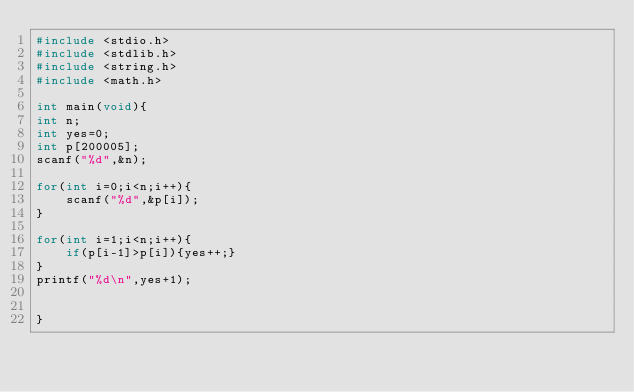<code> <loc_0><loc_0><loc_500><loc_500><_C_>#include <stdio.h>
#include <stdlib.h>
#include <string.h>
#include <math.h>

int main(void){
int n;
int yes=0;
int p[200005];
scanf("%d",&n);

for(int i=0;i<n;i++){
    scanf("%d",&p[i]);
}

for(int i=1;i<n;i++){
    if(p[i-1]>p[i]){yes++;}
}
printf("%d\n",yes+1);


}</code> 